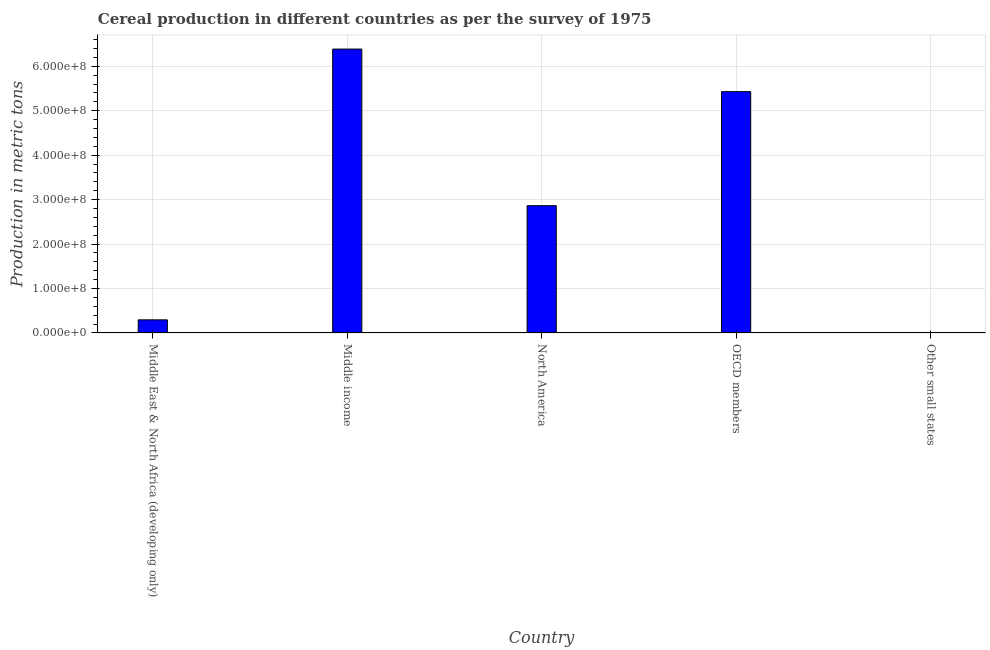Does the graph contain any zero values?
Give a very brief answer. No. What is the title of the graph?
Ensure brevity in your answer.  Cereal production in different countries as per the survey of 1975. What is the label or title of the Y-axis?
Offer a very short reply. Production in metric tons. What is the cereal production in North America?
Ensure brevity in your answer.  2.86e+08. Across all countries, what is the maximum cereal production?
Ensure brevity in your answer.  6.39e+08. Across all countries, what is the minimum cereal production?
Provide a short and direct response. 7.50e+05. In which country was the cereal production maximum?
Make the answer very short. Middle income. In which country was the cereal production minimum?
Keep it short and to the point. Other small states. What is the sum of the cereal production?
Make the answer very short. 1.50e+09. What is the difference between the cereal production in OECD members and Other small states?
Give a very brief answer. 5.42e+08. What is the average cereal production per country?
Offer a very short reply. 3.00e+08. What is the median cereal production?
Your answer should be compact. 2.86e+08. In how many countries, is the cereal production greater than 360000000 metric tons?
Offer a terse response. 2. What is the ratio of the cereal production in Middle East & North Africa (developing only) to that in Middle income?
Offer a very short reply. 0.05. Is the difference between the cereal production in Middle income and Other small states greater than the difference between any two countries?
Offer a very short reply. Yes. What is the difference between the highest and the second highest cereal production?
Give a very brief answer. 9.58e+07. What is the difference between the highest and the lowest cereal production?
Make the answer very short. 6.38e+08. Are all the bars in the graph horizontal?
Give a very brief answer. No. What is the difference between two consecutive major ticks on the Y-axis?
Give a very brief answer. 1.00e+08. What is the Production in metric tons of Middle East & North Africa (developing only)?
Provide a succinct answer. 2.94e+07. What is the Production in metric tons of Middle income?
Ensure brevity in your answer.  6.39e+08. What is the Production in metric tons of North America?
Keep it short and to the point. 2.86e+08. What is the Production in metric tons in OECD members?
Provide a succinct answer. 5.43e+08. What is the Production in metric tons of Other small states?
Your answer should be very brief. 7.50e+05. What is the difference between the Production in metric tons in Middle East & North Africa (developing only) and Middle income?
Offer a terse response. -6.09e+08. What is the difference between the Production in metric tons in Middle East & North Africa (developing only) and North America?
Offer a terse response. -2.57e+08. What is the difference between the Production in metric tons in Middle East & North Africa (developing only) and OECD members?
Your answer should be very brief. -5.14e+08. What is the difference between the Production in metric tons in Middle East & North Africa (developing only) and Other small states?
Make the answer very short. 2.87e+07. What is the difference between the Production in metric tons in Middle income and North America?
Give a very brief answer. 3.52e+08. What is the difference between the Production in metric tons in Middle income and OECD members?
Your response must be concise. 9.58e+07. What is the difference between the Production in metric tons in Middle income and Other small states?
Give a very brief answer. 6.38e+08. What is the difference between the Production in metric tons in North America and OECD members?
Offer a very short reply. -2.57e+08. What is the difference between the Production in metric tons in North America and Other small states?
Provide a succinct answer. 2.86e+08. What is the difference between the Production in metric tons in OECD members and Other small states?
Provide a short and direct response. 5.42e+08. What is the ratio of the Production in metric tons in Middle East & North Africa (developing only) to that in Middle income?
Your response must be concise. 0.05. What is the ratio of the Production in metric tons in Middle East & North Africa (developing only) to that in North America?
Give a very brief answer. 0.1. What is the ratio of the Production in metric tons in Middle East & North Africa (developing only) to that in OECD members?
Keep it short and to the point. 0.05. What is the ratio of the Production in metric tons in Middle East & North Africa (developing only) to that in Other small states?
Provide a succinct answer. 39.27. What is the ratio of the Production in metric tons in Middle income to that in North America?
Provide a succinct answer. 2.23. What is the ratio of the Production in metric tons in Middle income to that in OECD members?
Provide a succinct answer. 1.18. What is the ratio of the Production in metric tons in Middle income to that in Other small states?
Your answer should be very brief. 852.17. What is the ratio of the Production in metric tons in North America to that in OECD members?
Offer a very short reply. 0.53. What is the ratio of the Production in metric tons in North America to that in Other small states?
Ensure brevity in your answer.  382.05. What is the ratio of the Production in metric tons in OECD members to that in Other small states?
Ensure brevity in your answer.  724.35. 